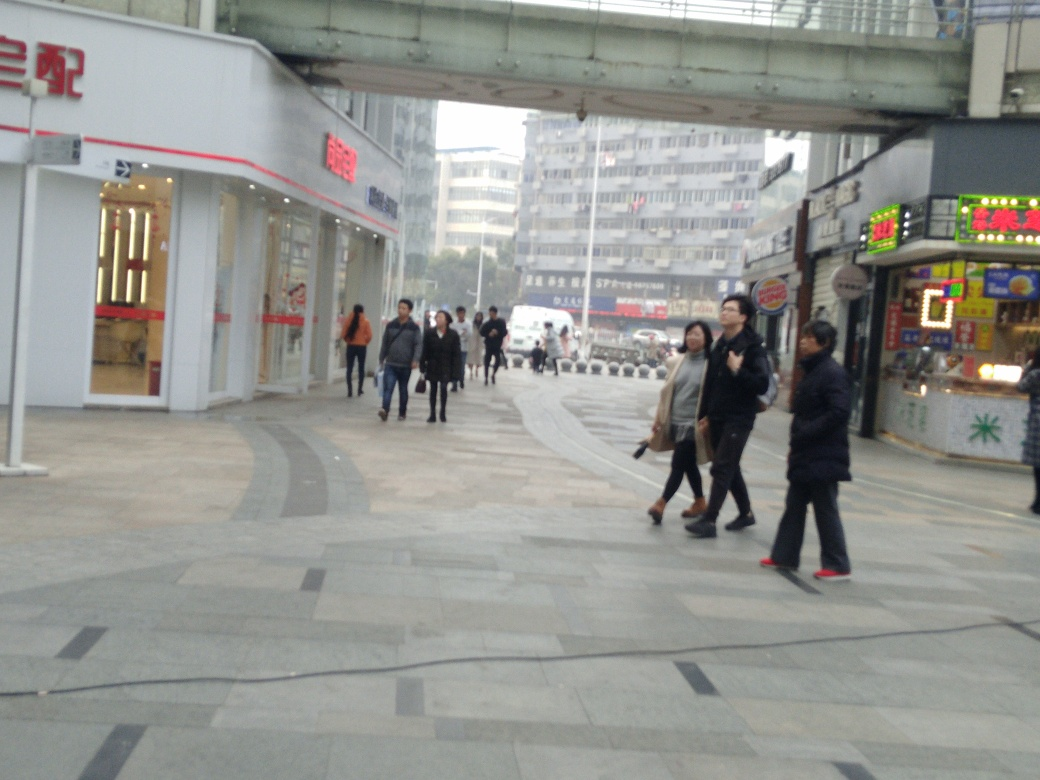Can you describe the overall mood of the scene depicted in the image? The scene appears to be set in a bustling urban area with pedestrians going about their day, which gives it a dynamic and lively mood. The overcast sky and absence of bright sunshine add a calm and subdued tone to the image. 